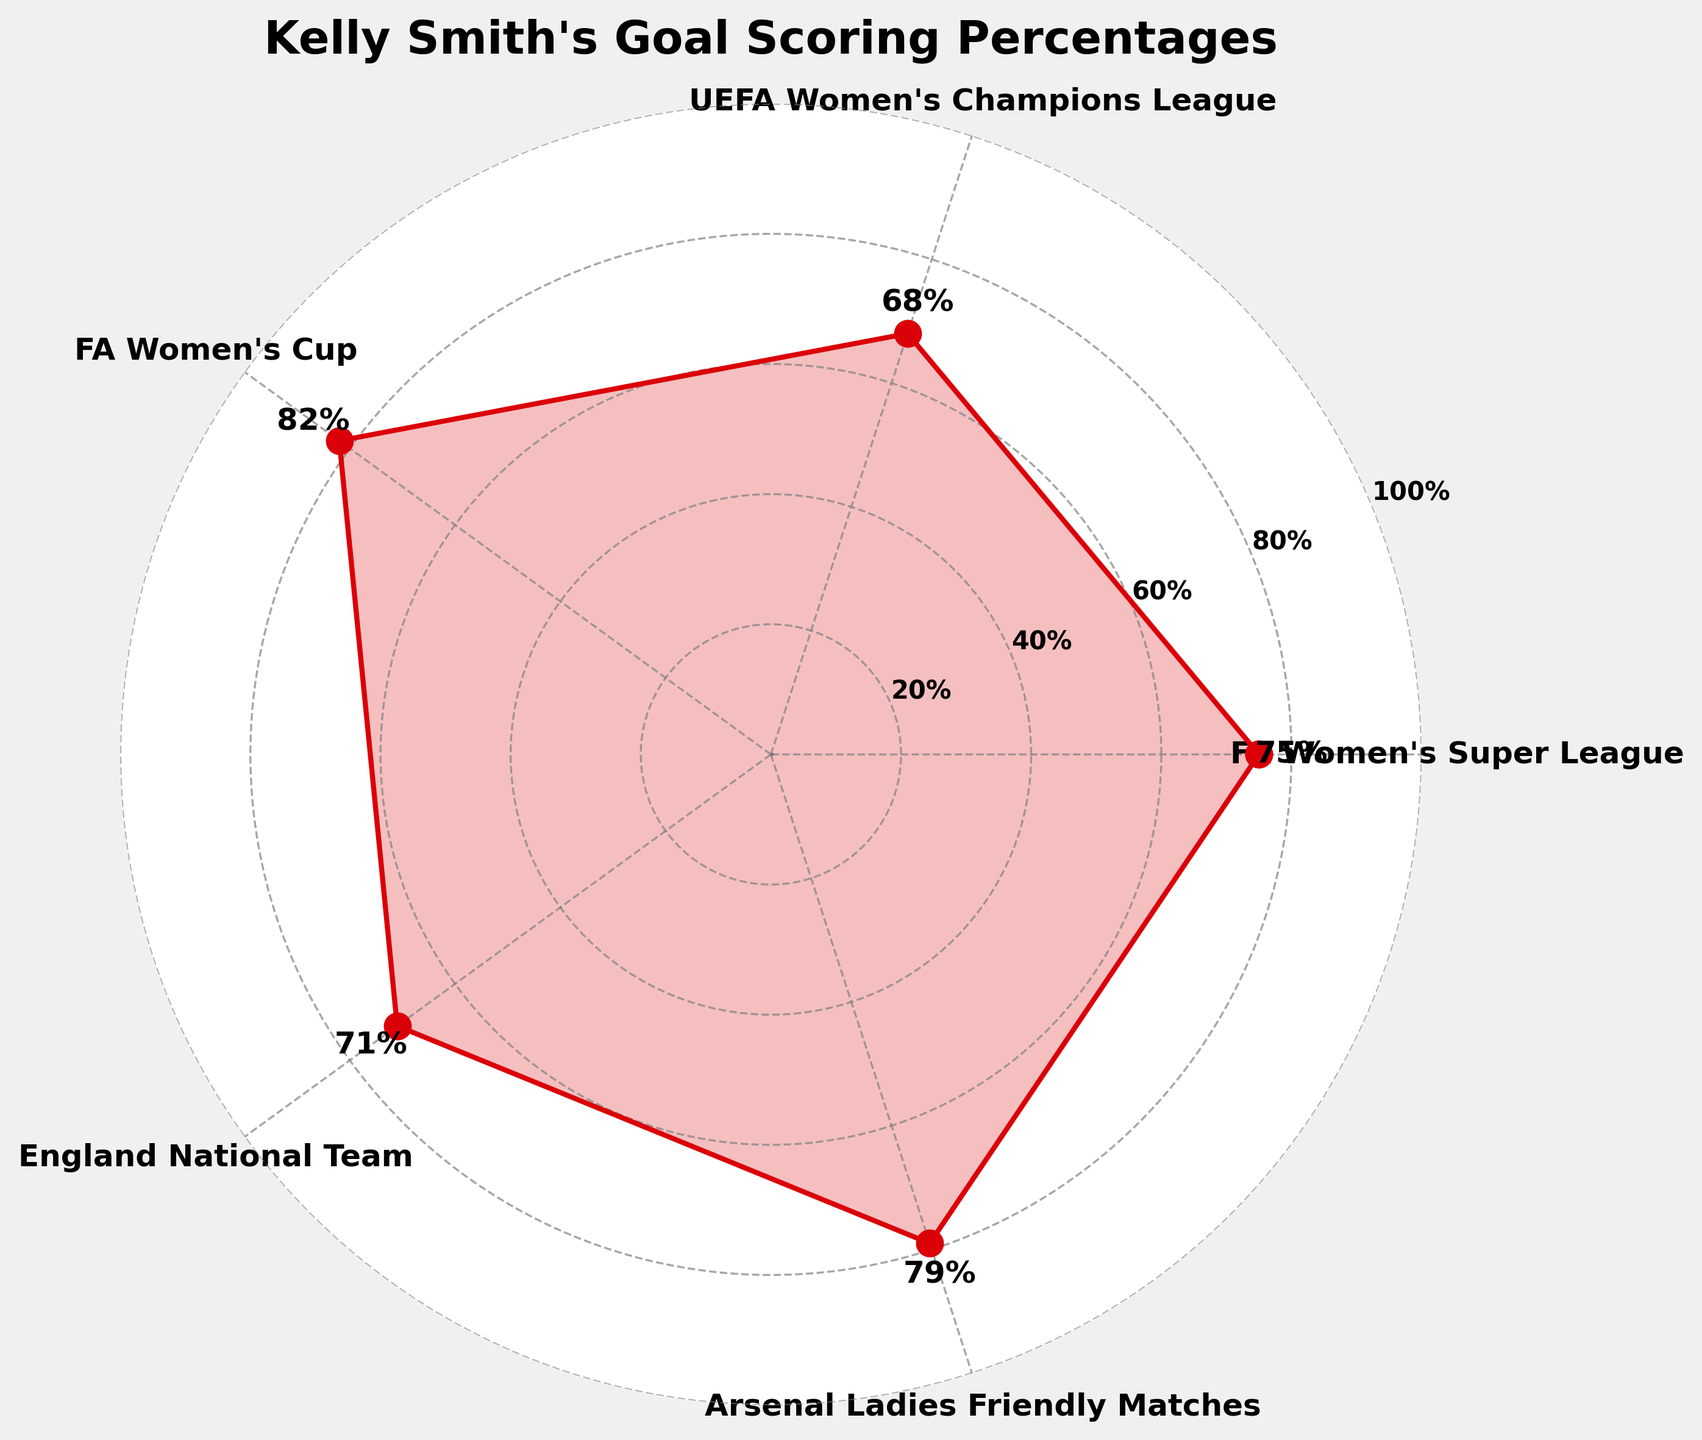What's the title of the figure? The title is typically displayed at the top of the figure and describes the main topic or theme.
Answer: Kelly Smith's Goal Scoring Percentages What is the highest goal scoring percentage shown? To find this, one should look at the different percentages indicated on the figure and identify the maximum value. The highest value in the figure is 82%.
Answer: 82% Which competition has the lowest goal scoring percentage? This requires identifying the lowest percentage among all the competitions listed. By examining the percentages, the lowest is 68%, which corresponds to the UEFA Women's Champions League.
Answer: UEFA Women's Champions League How many different competitions are represented in the figure? Count the number of unique data points or labels around the polar chart. In this case, there are 5 competitions represented.
Answer: 5 What is the average goal scoring percentage across all competitions? Calculate the average by summing all the percentages and dividing by the number of competitions. (75% + 68% + 82% + 71% + 79%) / 5 = 75%
Answer: 75% Which competitions have goal scoring percentages above 70%? Check each competition's percentage and see which ones are above 70%. FA Women's Super League, FA Women's Cup, England National Team, and Arsenal Ladies Friendly Matches all have percentages exceeding 70%.
Answer: FA Women's Super League, FA Women's Cup, England National Team, Arsenal Ladies Friendly Matches Which competition has the closest goal scoring percentage to the average? First, calculate the average as 75%. Then, identify which percentage is closest to this value. The closest percentage to 75% is FA Women's Super League, which is exactly at 75%.
Answer: FA Women's Super League What's the range of goal scoring percentages? The range is calculated by subtracting the lowest percentage from the highest percentage. Highest: 82%, Lowest: 68%, thus the range is 82% - 68% = 14%.
Answer: 14% In how many competitions does Kelly Smith have a goal scoring percentage of 75% or higher? Count the number of competition percentages that are 75% or more. The competitions are FA Women's Super League, FA Women's Cup, England National Team, and Arsenal Ladies Friendly Matches. That's 4 competitions.
Answer: 4 How much higher is Kelly Smith's goal scoring percentage in the FA Women's Cup compared to the UEFA Women's Champions League? Subtract the percentage in the UEFA Women's Champions League from the percentage in the FA Women's Cup. 82% - 68% = 14% higher.
Answer: 14% higher 